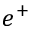<formula> <loc_0><loc_0><loc_500><loc_500>e ^ { + }</formula> 